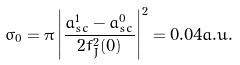<formula> <loc_0><loc_0><loc_500><loc_500>\sigma _ { 0 } = \pi \left | \frac { a _ { s c } ^ { 1 } - a _ { s c } ^ { 0 } } { 2 f ^ { 2 } _ { J } ( 0 ) } \right | ^ { 2 } = 0 . 0 4 a . u .</formula> 